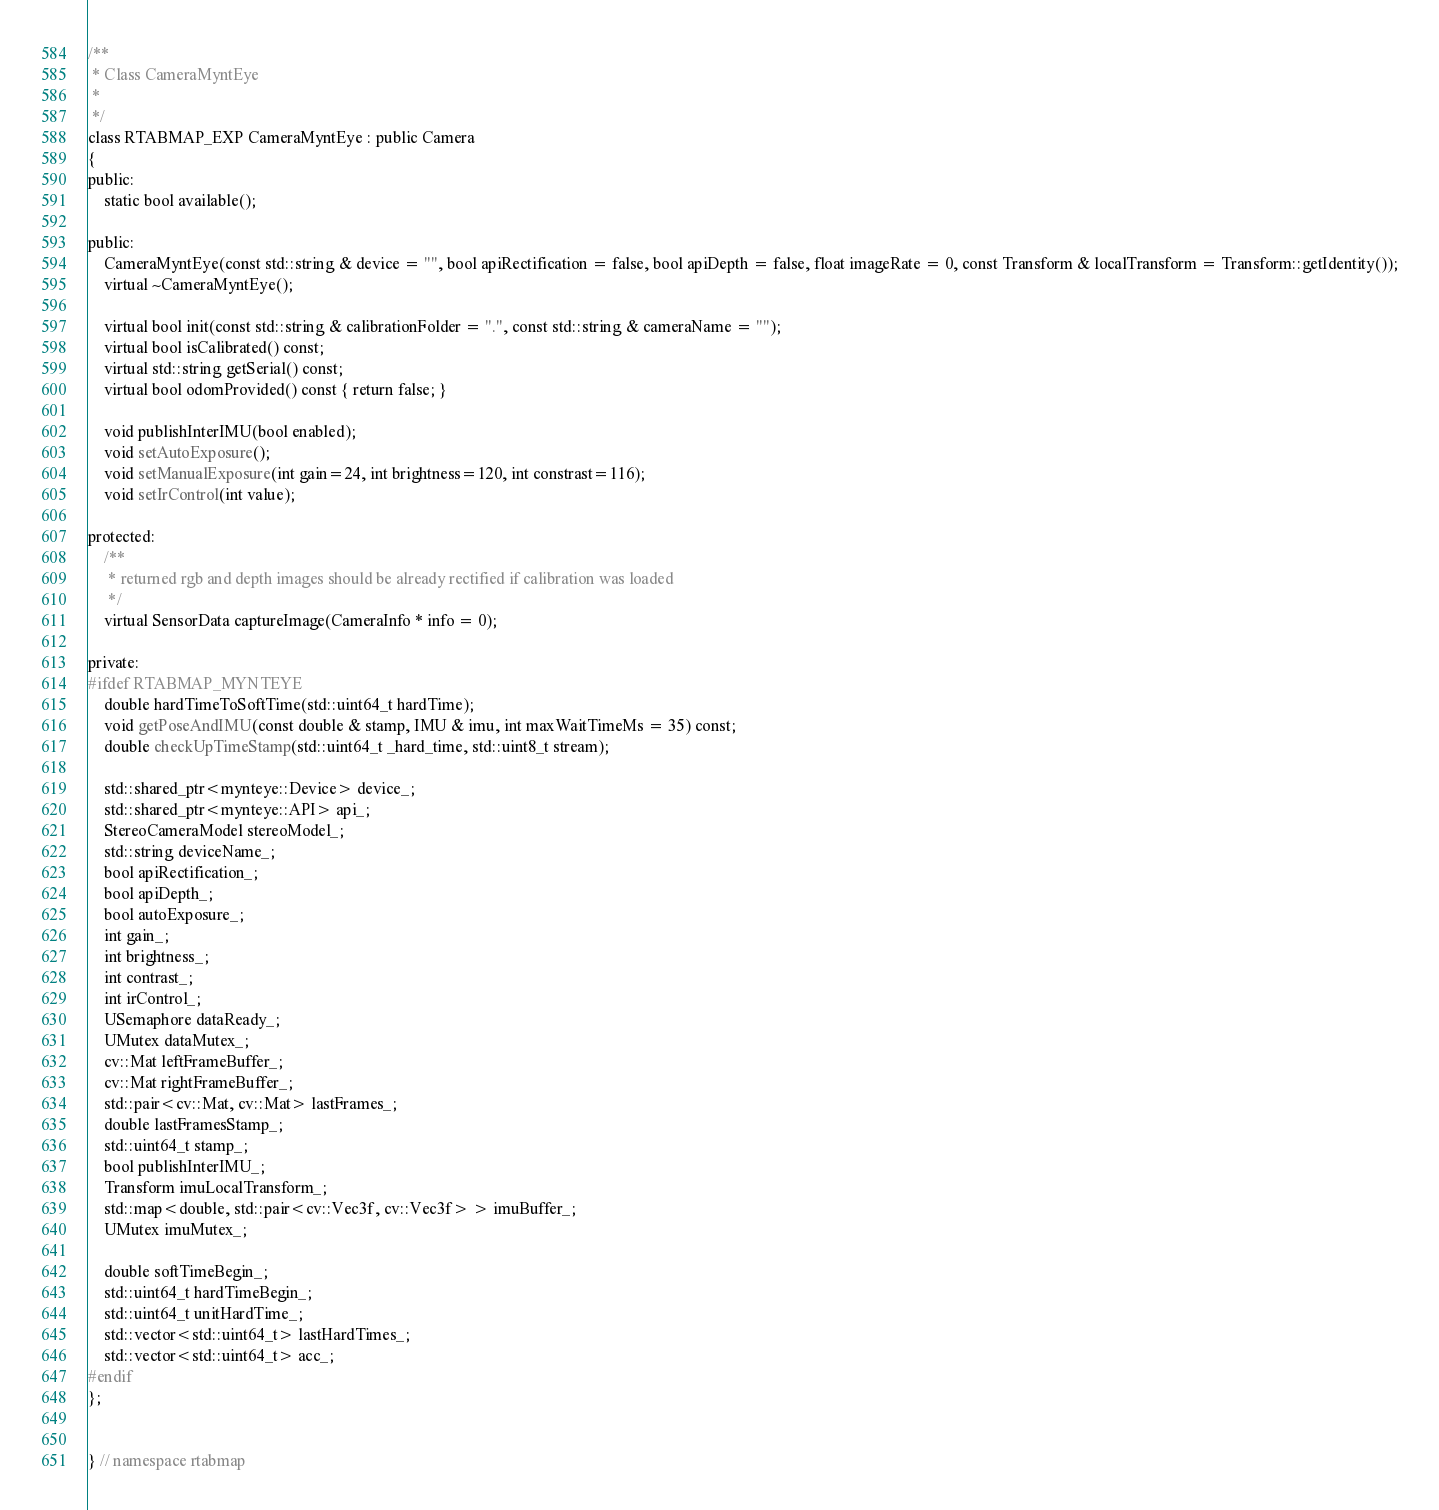<code> <loc_0><loc_0><loc_500><loc_500><_C_>
/**
 * Class CameraMyntEye
 *
 */
class RTABMAP_EXP CameraMyntEye : public Camera
{
public:
	static bool available();

public:
	CameraMyntEye(const std::string & device = "", bool apiRectification = false, bool apiDepth = false, float imageRate = 0, const Transform & localTransform = Transform::getIdentity());
	virtual ~CameraMyntEye();

	virtual bool init(const std::string & calibrationFolder = ".", const std::string & cameraName = "");
	virtual bool isCalibrated() const;
	virtual std::string getSerial() const;
	virtual bool odomProvided() const { return false; }

	void publishInterIMU(bool enabled);
	void setAutoExposure();
	void setManualExposure(int gain=24, int brightness=120, int constrast=116);
	void setIrControl(int value);

protected:
	/**
	 * returned rgb and depth images should be already rectified if calibration was loaded
	 */
	virtual SensorData captureImage(CameraInfo * info = 0);

private:
#ifdef RTABMAP_MYNTEYE
	double hardTimeToSoftTime(std::uint64_t hardTime);
	void getPoseAndIMU(const double & stamp, IMU & imu, int maxWaitTimeMs = 35) const;
	double checkUpTimeStamp(std::uint64_t _hard_time, std::uint8_t stream);

	std::shared_ptr<mynteye::Device> device_;
	std::shared_ptr<mynteye::API> api_;
	StereoCameraModel stereoModel_;
	std::string deviceName_;
	bool apiRectification_;
	bool apiDepth_;
	bool autoExposure_;
	int gain_;
	int brightness_;
	int contrast_;
	int irControl_;
	USemaphore dataReady_;
	UMutex dataMutex_;
	cv::Mat leftFrameBuffer_;
	cv::Mat rightFrameBuffer_;
	std::pair<cv::Mat, cv::Mat> lastFrames_;
	double lastFramesStamp_;
	std::uint64_t stamp_;
	bool publishInterIMU_;
	Transform imuLocalTransform_;
	std::map<double, std::pair<cv::Vec3f, cv::Vec3f> > imuBuffer_;
	UMutex imuMutex_;

	double softTimeBegin_;
	std::uint64_t hardTimeBegin_;
	std::uint64_t unitHardTime_;
	std::vector<std::uint64_t> lastHardTimes_;
	std::vector<std::uint64_t> acc_;
#endif
};


} // namespace rtabmap
</code> 